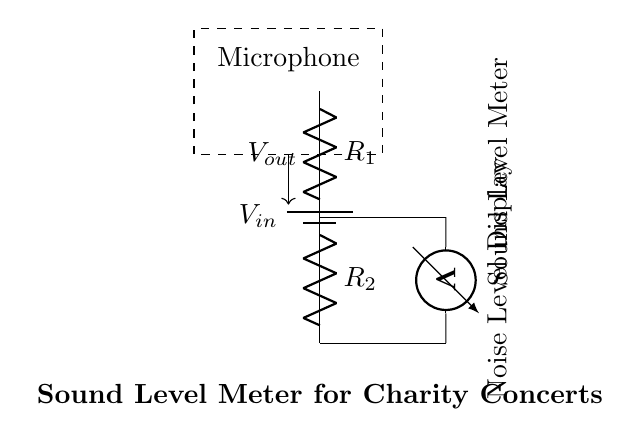What is the primary function of this circuit? The primary function of this circuit is to measure sound levels, converting acoustic signals to electrical signals for monitoring.
Answer: Measure sound levels Which component acts as the input device in this circuit? The microphone acts as the input device by converting sound waves into electrical voltage signals.
Answer: Microphone What is the role of the resistor labeled R1? R1 is part of the voltage divider that sets the proportion of input voltage relative to the resistors in the circuit, affecting the output voltage.
Answer: Voltage divider What is the output measurement taken by this circuit? The circuit outputs the voltage which corresponds to the sound level detected by the microphone, shown on the sound level meter.
Answer: Voltage How does changing the value of resistor R2 affect the output voltage? Increasing R2 will decrease the output voltage, as the voltage divider formula shows that a larger R2 results in a smaller voltage drop across it.
Answer: Decrease output voltage What type of circuit configuration is used here? The configuration used here is a voltage divider, which is specifically designed to reduce voltage levels for measurement purposes.
Answer: Voltage divider 